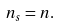<formula> <loc_0><loc_0><loc_500><loc_500>n _ { s } = n .</formula> 